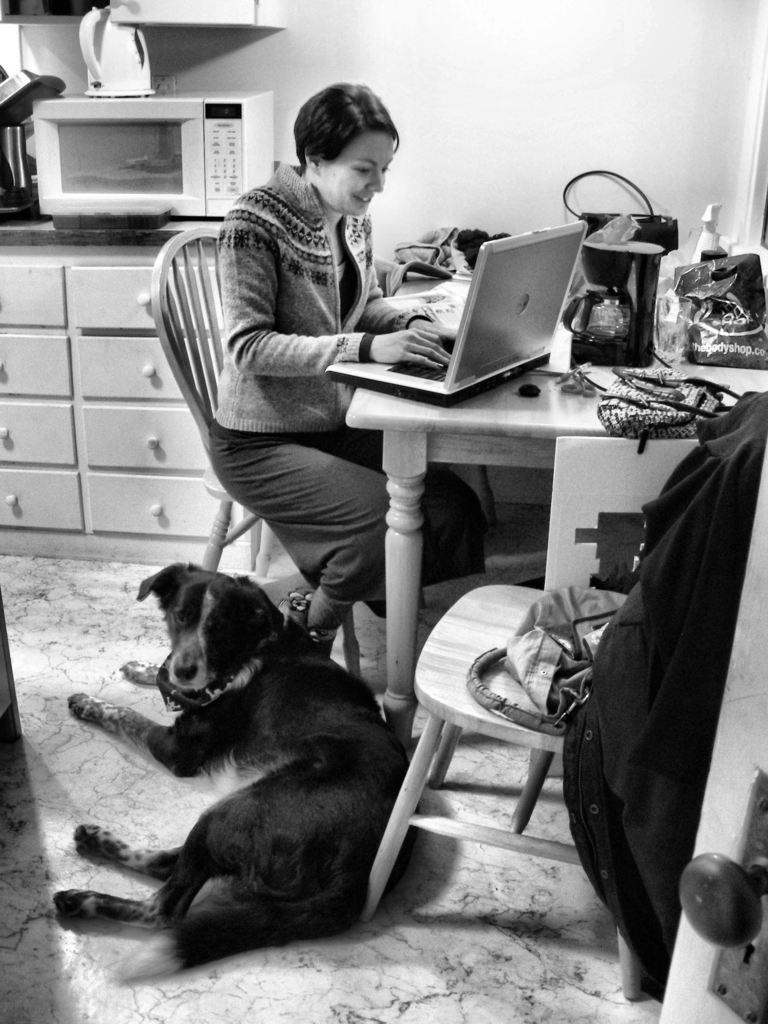What type of animal can be seen in the image? There is a black dog in the image. What is the woman in the image doing? The woman is sitting on a chair and operating a laptop in the image. Where is the laptop located? The laptop is present on a table in the image. What other appliance can be seen in the image? There is a microwave visible in the image. What type of boundary can be seen in the image? There is no boundary present in the image. What time of day is depicted in the image? The time of day cannot be determined from the image. 